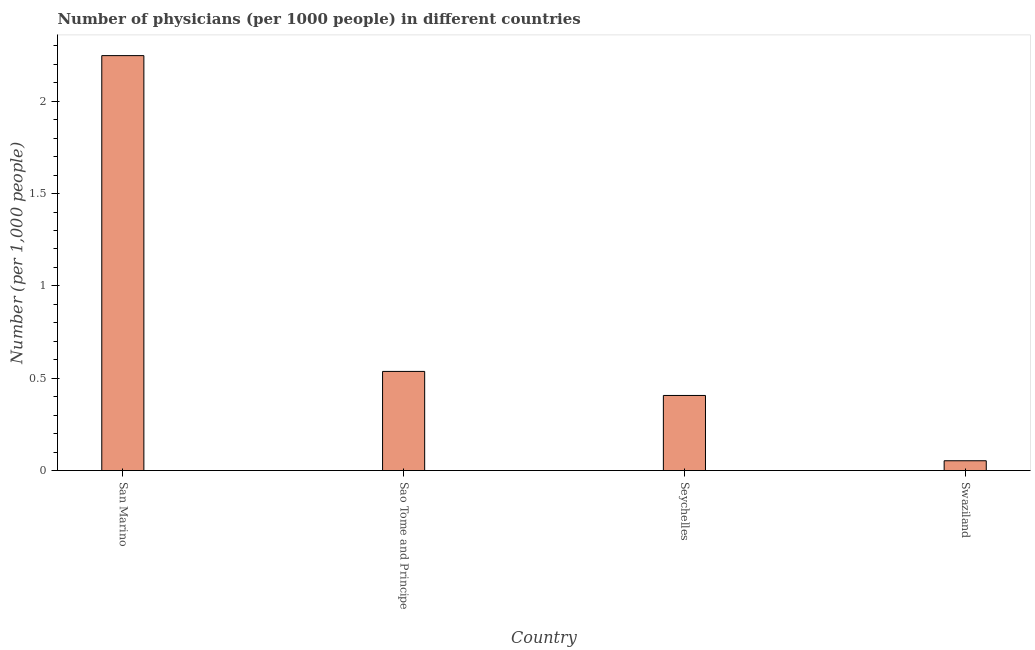What is the title of the graph?
Your answer should be compact. Number of physicians (per 1000 people) in different countries. What is the label or title of the Y-axis?
Offer a terse response. Number (per 1,0 people). What is the number of physicians in San Marino?
Keep it short and to the point. 2.25. Across all countries, what is the maximum number of physicians?
Provide a succinct answer. 2.25. Across all countries, what is the minimum number of physicians?
Your answer should be compact. 0.05. In which country was the number of physicians maximum?
Offer a very short reply. San Marino. In which country was the number of physicians minimum?
Provide a succinct answer. Swaziland. What is the sum of the number of physicians?
Offer a very short reply. 3.24. What is the difference between the number of physicians in San Marino and Seychelles?
Your response must be concise. 1.84. What is the average number of physicians per country?
Provide a succinct answer. 0.81. What is the median number of physicians?
Your answer should be very brief. 0.47. In how many countries, is the number of physicians greater than 2 ?
Your answer should be compact. 1. What is the ratio of the number of physicians in Sao Tome and Principe to that in Swaziland?
Offer a terse response. 10.09. What is the difference between the highest and the second highest number of physicians?
Give a very brief answer. 1.71. What is the difference between the highest and the lowest number of physicians?
Keep it short and to the point. 2.19. How many bars are there?
Offer a very short reply. 4. How many countries are there in the graph?
Ensure brevity in your answer.  4. What is the Number (per 1,000 people) in San Marino?
Your response must be concise. 2.25. What is the Number (per 1,000 people) of Sao Tome and Principe?
Your answer should be compact. 0.54. What is the Number (per 1,000 people) in Seychelles?
Provide a succinct answer. 0.41. What is the Number (per 1,000 people) in Swaziland?
Your response must be concise. 0.05. What is the difference between the Number (per 1,000 people) in San Marino and Sao Tome and Principe?
Provide a short and direct response. 1.71. What is the difference between the Number (per 1,000 people) in San Marino and Seychelles?
Your answer should be compact. 1.84. What is the difference between the Number (per 1,000 people) in San Marino and Swaziland?
Keep it short and to the point. 2.19. What is the difference between the Number (per 1,000 people) in Sao Tome and Principe and Seychelles?
Provide a succinct answer. 0.13. What is the difference between the Number (per 1,000 people) in Sao Tome and Principe and Swaziland?
Your response must be concise. 0.48. What is the difference between the Number (per 1,000 people) in Seychelles and Swaziland?
Ensure brevity in your answer.  0.35. What is the ratio of the Number (per 1,000 people) in San Marino to that in Sao Tome and Principe?
Your answer should be compact. 4.18. What is the ratio of the Number (per 1,000 people) in San Marino to that in Seychelles?
Give a very brief answer. 5.52. What is the ratio of the Number (per 1,000 people) in San Marino to that in Swaziland?
Keep it short and to the point. 42.24. What is the ratio of the Number (per 1,000 people) in Sao Tome and Principe to that in Seychelles?
Your response must be concise. 1.32. What is the ratio of the Number (per 1,000 people) in Sao Tome and Principe to that in Swaziland?
Your answer should be very brief. 10.09. What is the ratio of the Number (per 1,000 people) in Seychelles to that in Swaziland?
Your answer should be compact. 7.65. 